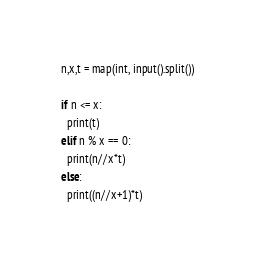Convert code to text. <code><loc_0><loc_0><loc_500><loc_500><_Python_>n,x,t = map(int, input().split())
 
if n <= x:
  print(t)
elif n % x == 0:
  print(n//x*t)
else:
  print((n//x+1)*t)</code> 